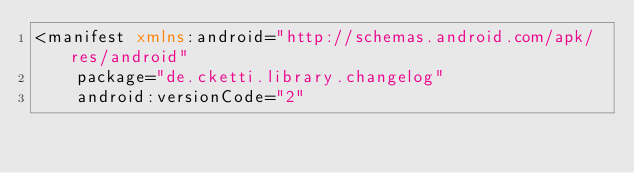Convert code to text. <code><loc_0><loc_0><loc_500><loc_500><_XML_><manifest xmlns:android="http://schemas.android.com/apk/res/android"
    package="de.cketti.library.changelog"
    android:versionCode="2"</code> 